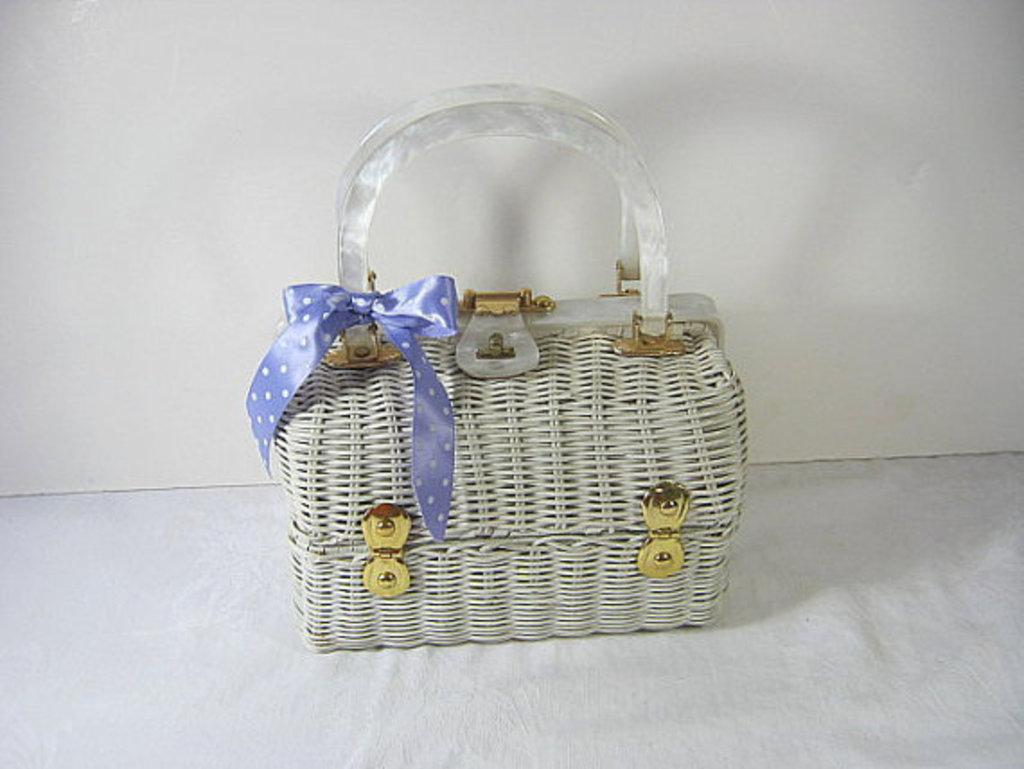What object can be seen in the image? There is a box in the image. Is there anything attached to the box? Yes, there is a ribbon tied to the box. What type of organization is responsible for the oil in the image? There is no oil present in the image, so it is not possible to determine which organization might be responsible for it. 